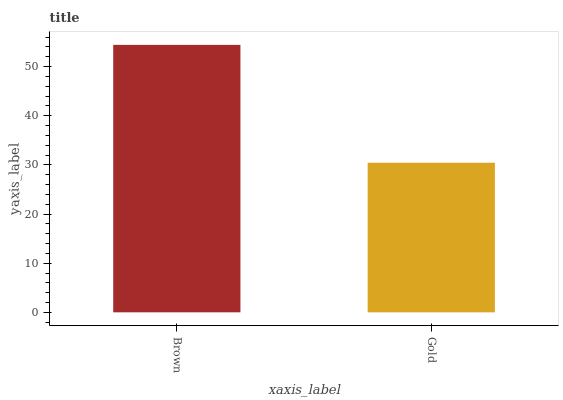Is Gold the minimum?
Answer yes or no. Yes. Is Brown the maximum?
Answer yes or no. Yes. Is Gold the maximum?
Answer yes or no. No. Is Brown greater than Gold?
Answer yes or no. Yes. Is Gold less than Brown?
Answer yes or no. Yes. Is Gold greater than Brown?
Answer yes or no. No. Is Brown less than Gold?
Answer yes or no. No. Is Brown the high median?
Answer yes or no. Yes. Is Gold the low median?
Answer yes or no. Yes. Is Gold the high median?
Answer yes or no. No. Is Brown the low median?
Answer yes or no. No. 